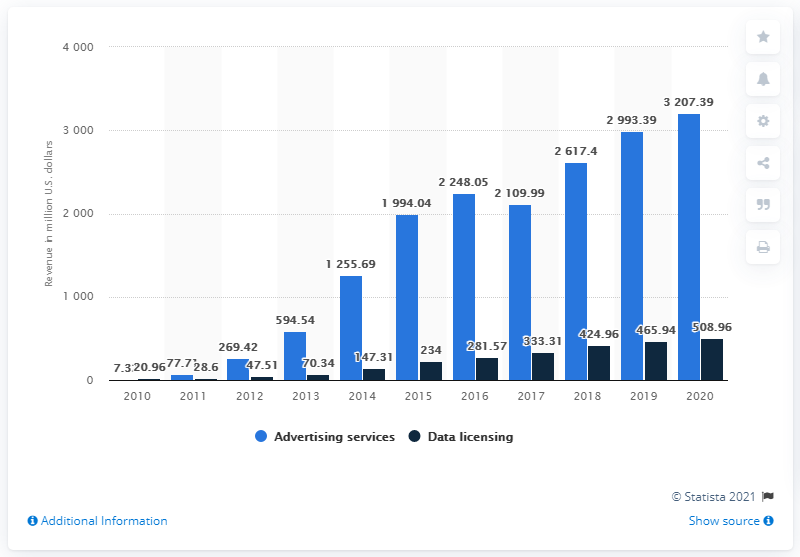What could be inferred about Twitter's business performance in the year 2015? In 2015, there is a noticeable increase in Twitter's advertising revenue to $2.248.05 million, a significant jump from the previous year. This could imply that Twitter's business performance in terms of advertising services was particularly strong in that year. 